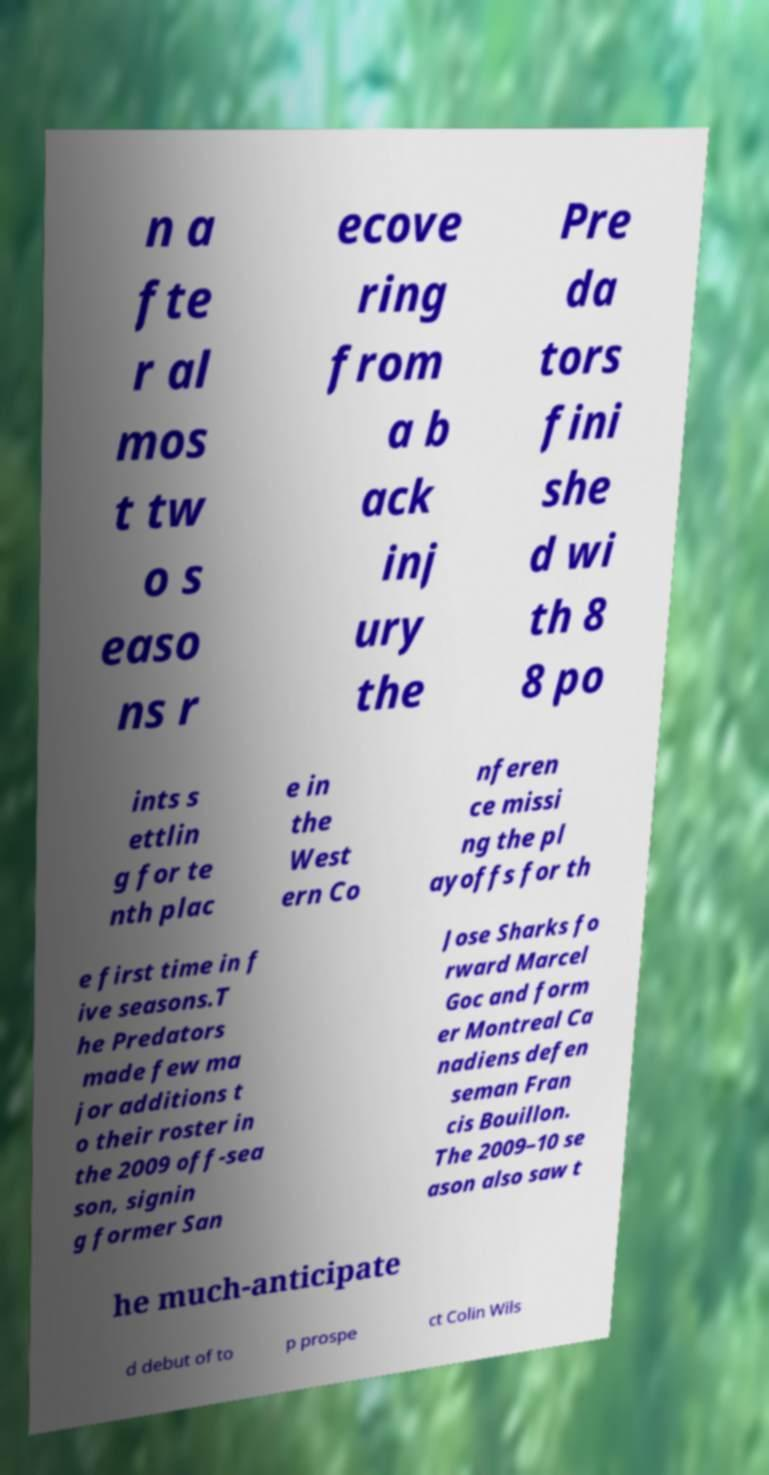What messages or text are displayed in this image? I need them in a readable, typed format. n a fte r al mos t tw o s easo ns r ecove ring from a b ack inj ury the Pre da tors fini she d wi th 8 8 po ints s ettlin g for te nth plac e in the West ern Co nferen ce missi ng the pl ayoffs for th e first time in f ive seasons.T he Predators made few ma jor additions t o their roster in the 2009 off-sea son, signin g former San Jose Sharks fo rward Marcel Goc and form er Montreal Ca nadiens defen seman Fran cis Bouillon. The 2009–10 se ason also saw t he much-anticipate d debut of to p prospe ct Colin Wils 